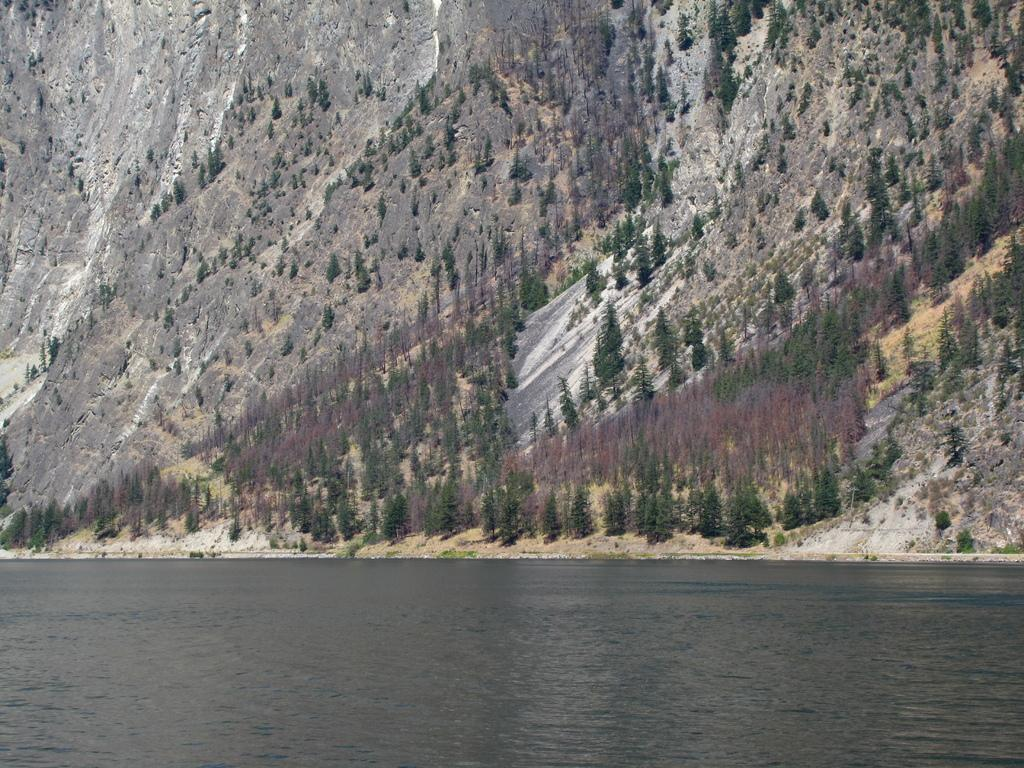What is the primary element visible in the image? There is water in the image. What geographical feature can be seen in the image? There is a hill in the image. What type of vegetation is present in the image? There are trees in the image. Can you tell me where the sister is protesting in the image? There is no sister or protest present in the image; it features water, a hill, and trees. What type of plant is growing on the hill in the image? There is no specific plant mentioned or visible in the image; it only shows trees and water. 